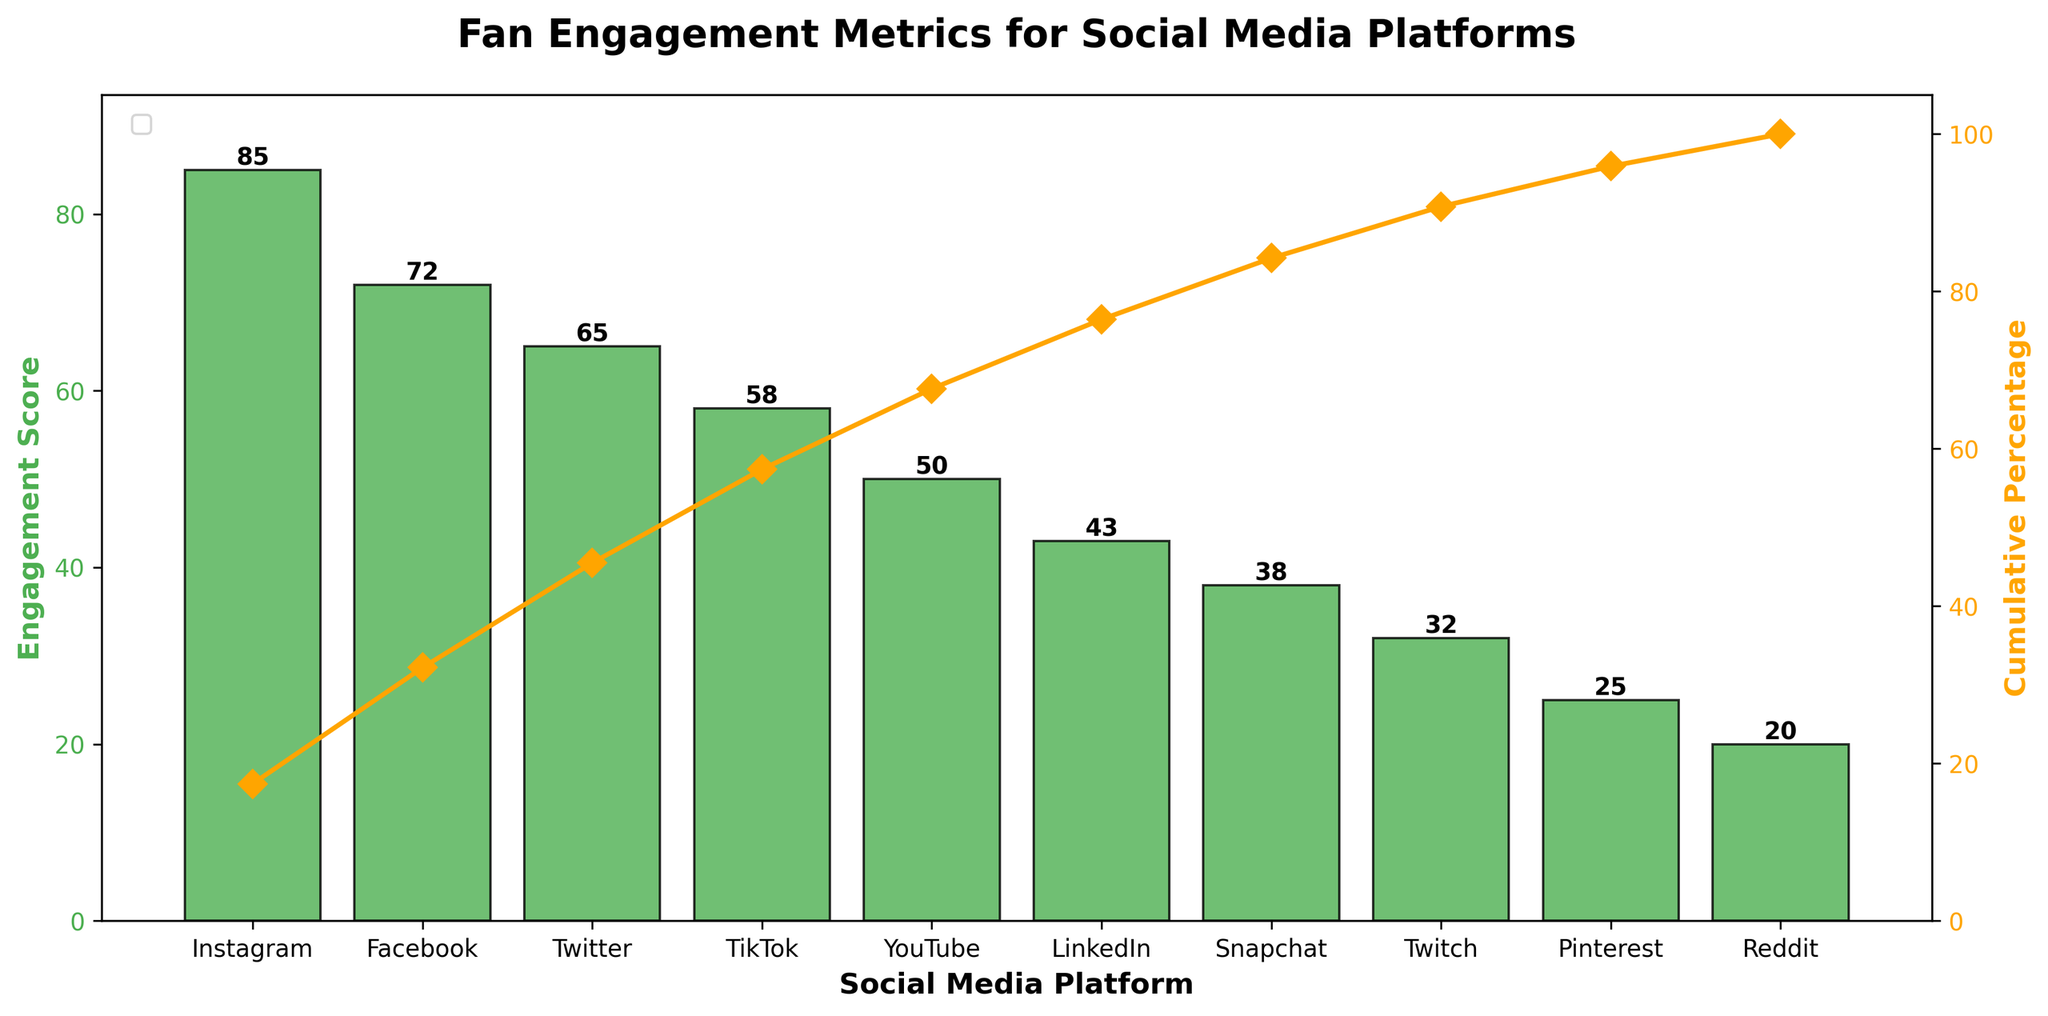What is the title of the chart? The title is typically displayed at the top or center of the chart, and it gives a summary about what the chart represents. In this case, it says "Fan Engagement Metrics for Social Media Platforms".
Answer: Fan Engagement Metrics for Social Media Platforms Which social media platform has the highest engagement score? To find the platform with the highest engagement score, refer to the tallest bar on the bar chart. In this figure, the tallest bar represents Instagram with an engagement score of 85.
Answer: Instagram How many social media platforms are represented in the chart? Count the number of bars in the bar chart since each bar represents a platform. There are 10 bars, indicating 10 platforms.
Answer: 10 What is the cumulative percentage of TikTok? Locate TikTok on the x-axis and trace the corresponding point on the cumulative percentage line (orange line). TikTok's cumulative percentage is 76%.
Answer: 76% What is the cumulative percentage for platforms up to Snapchat? To get this, sum the cumulative percentages for all platforms up to Snapchat. These are Instagram (85), Facebook (72), Twitter (65), TikTok (58), YouTube (50), LinkedIn (43), and Snapchat (38). The total engagement score is 411, and the sum of these scores divided by the total (488) gives the cumulative percentage: (411/488)*100 ≈ 84%.
Answer: 84% Which platform ranks higher in engagement: LinkedIn or Snapchat? Compare the heights of the bars for LinkedIn and Snapchat. LinkedIn's bar is higher than Snapchat's, indicating it has a higher engagement score (43 vs. 38).
Answer: LinkedIn What engagement score does Twitch have? Locate the bar for Twitch and check its height or the number written on top of the bar. Twitch has an engagement score of 32.
Answer: 32 How does the cumulative percentage help to identify the most impactful platforms? The cumulative percentage line (orange line) shows how the engagement scores accumulate across platforms. Platforms at the top of the chart (left side) account for a larger portion of the total engagement, helping to identify which platforms are the most impactful. For example, Instagram, Facebook, and Twitter collectively make up a significant part of the cumulative percentage quickly.
Answer: It highlights key platforms What are the top three platforms in terms of engagement score? Identify the three tallest bars in the chart, which correspond to Instagram, Facebook, and Twitter, ordered from highest to lowest.
Answer: Instagram, Facebook, Twitter 